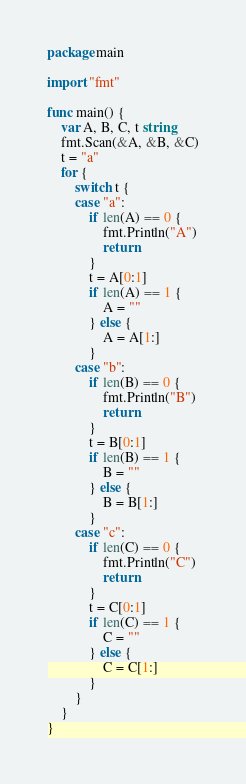Convert code to text. <code><loc_0><loc_0><loc_500><loc_500><_Go_>package main

import "fmt"

func main() {
	var A, B, C, t string
	fmt.Scan(&A, &B, &C)
	t = "a"
	for {
		switch t {
		case "a":
			if len(A) == 0 {
				fmt.Println("A")
				return
			}
			t = A[0:1]
			if len(A) == 1 {
				A = ""
			} else {
				A = A[1:]
			}
		case "b":
			if len(B) == 0 {
				fmt.Println("B")
				return
			}
			t = B[0:1]
			if len(B) == 1 {
				B = ""
			} else {
				B = B[1:]
			}
		case "c":
			if len(C) == 0 {
				fmt.Println("C")
				return
			}
			t = C[0:1]
			if len(C) == 1 {
				C = ""
			} else {
				C = C[1:]
			}
		}
	}
}</code> 